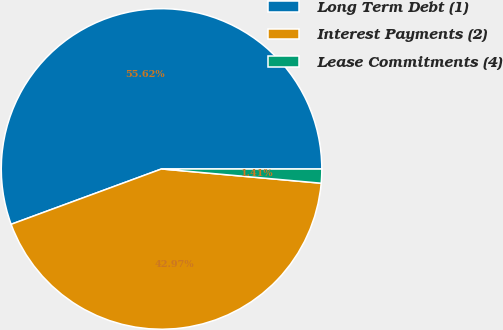Convert chart to OTSL. <chart><loc_0><loc_0><loc_500><loc_500><pie_chart><fcel>Long Term Debt (1)<fcel>Interest Payments (2)<fcel>Lease Commitments (4)<nl><fcel>55.62%<fcel>42.97%<fcel>1.41%<nl></chart> 